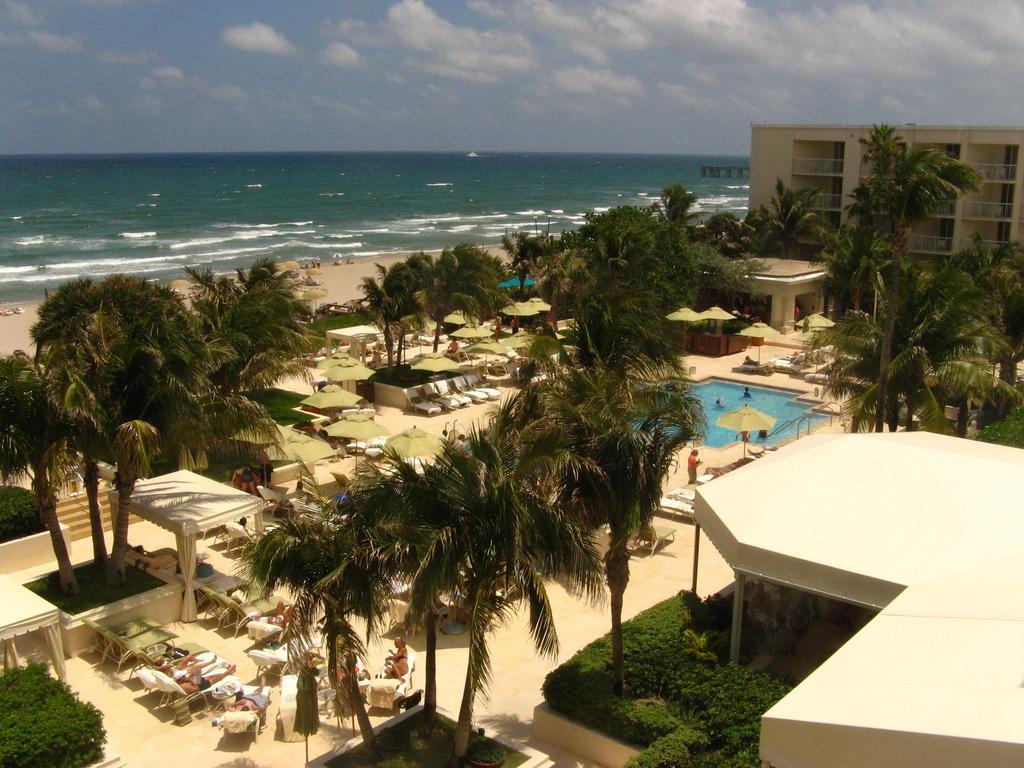Please provide a concise description of this image. This image is taken at seashore area. In this image we can see there are few buildings, trees, tents and benches. In the middle of the building there is a swimming pool. In the background there is a river and sky. 